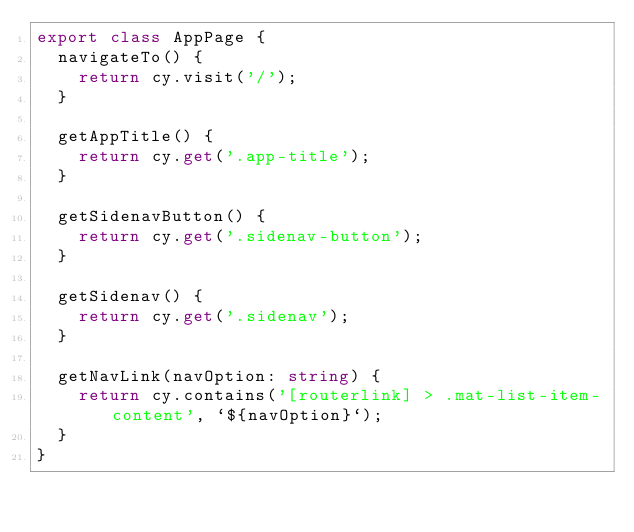<code> <loc_0><loc_0><loc_500><loc_500><_TypeScript_>export class AppPage {
  navigateTo() {
    return cy.visit('/');
  }

  getAppTitle() {
    return cy.get('.app-title');
  }

  getSidenavButton() {
    return cy.get('.sidenav-button');
  }

  getSidenav() {
    return cy.get('.sidenav');
  }

  getNavLink(navOption: string) {
    return cy.contains('[routerlink] > .mat-list-item-content', `${navOption}`);
  }
}
</code> 